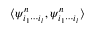<formula> <loc_0><loc_0><loc_500><loc_500>\langle \psi _ { i _ { 1 } \cdots i _ { l } } ^ { n } , \psi _ { i _ { 1 } \cdots i _ { l } } ^ { n } \rangle</formula> 